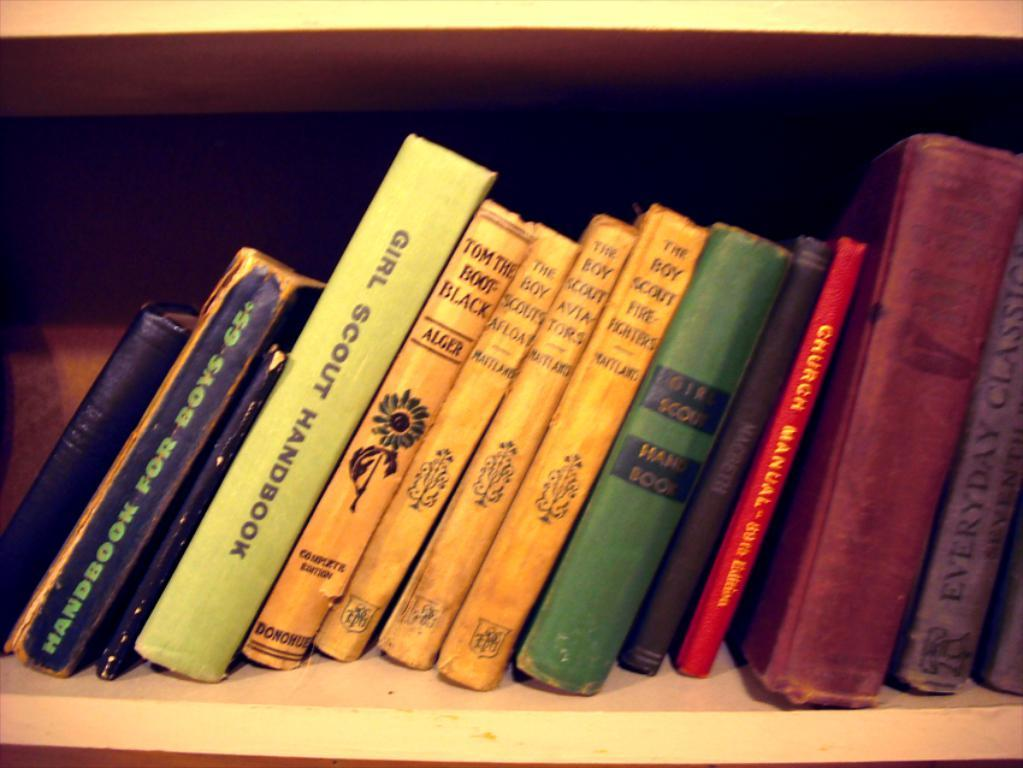<image>
Render a clear and concise summary of the photo. Books for both Boy Scouts and Girl Scouts are on the shelf. 